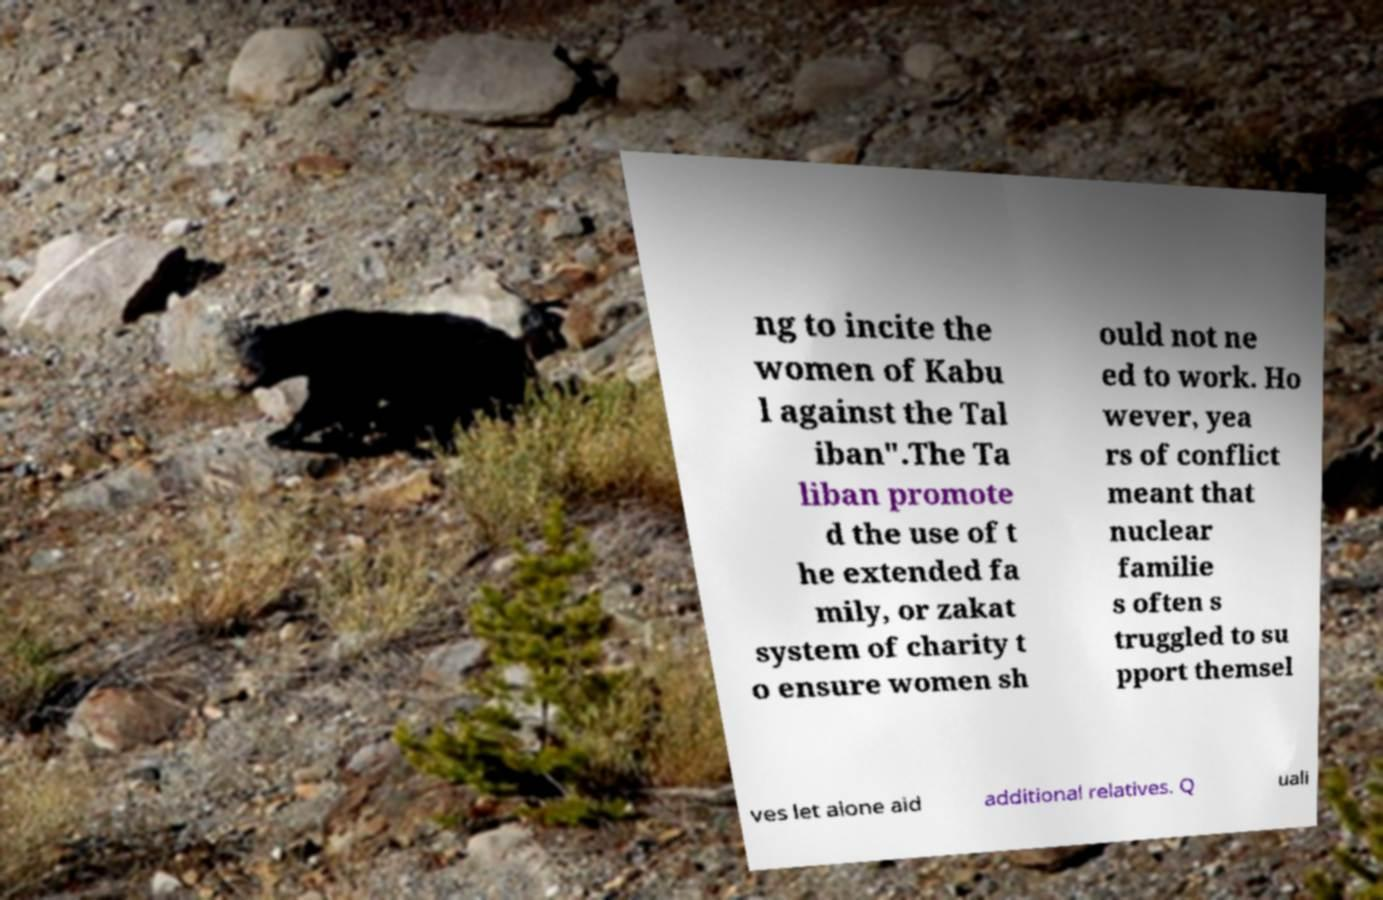Please read and relay the text visible in this image. What does it say? ng to incite the women of Kabu l against the Tal iban".The Ta liban promote d the use of t he extended fa mily, or zakat system of charity t o ensure women sh ould not ne ed to work. Ho wever, yea rs of conflict meant that nuclear familie s often s truggled to su pport themsel ves let alone aid additional relatives. Q uali 